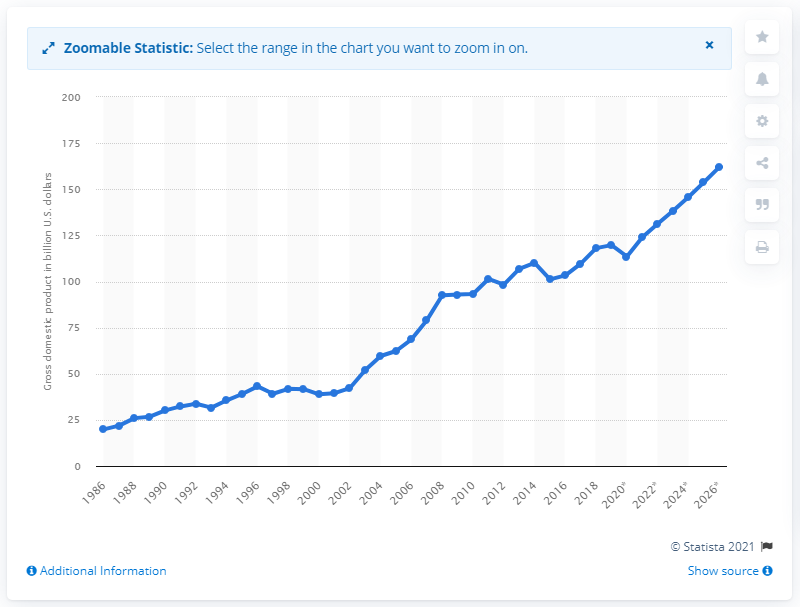Mention a couple of crucial points in this snapshot. In 2019, Morocco's gross domestic product was 119.7 billion dollars. 